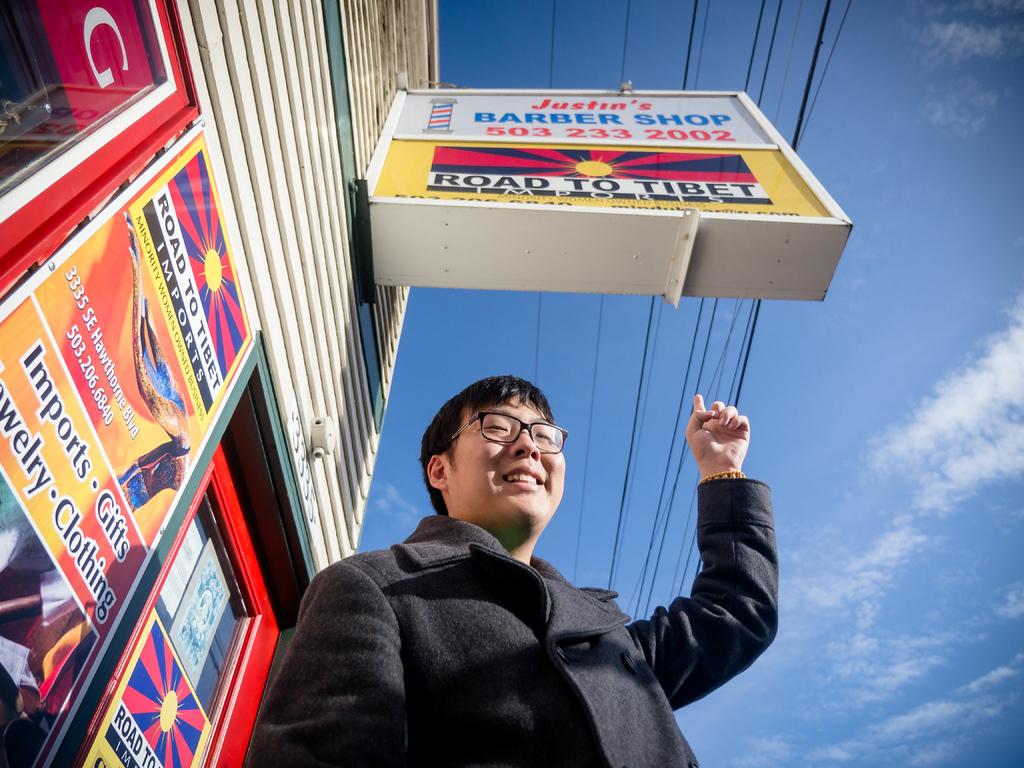Road to what?
Your answer should be compact. Tibet. What is the phone number of justin's barber shop?
Your answer should be compact. 503 233 2002. 